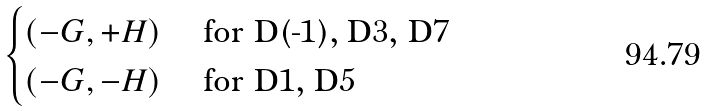<formula> <loc_0><loc_0><loc_500><loc_500>\begin{cases} ( - G , + H ) & \text { for D(-1), D3, D7} \\ ( - G , - H ) & \text { for D1, D5} \end{cases}</formula> 